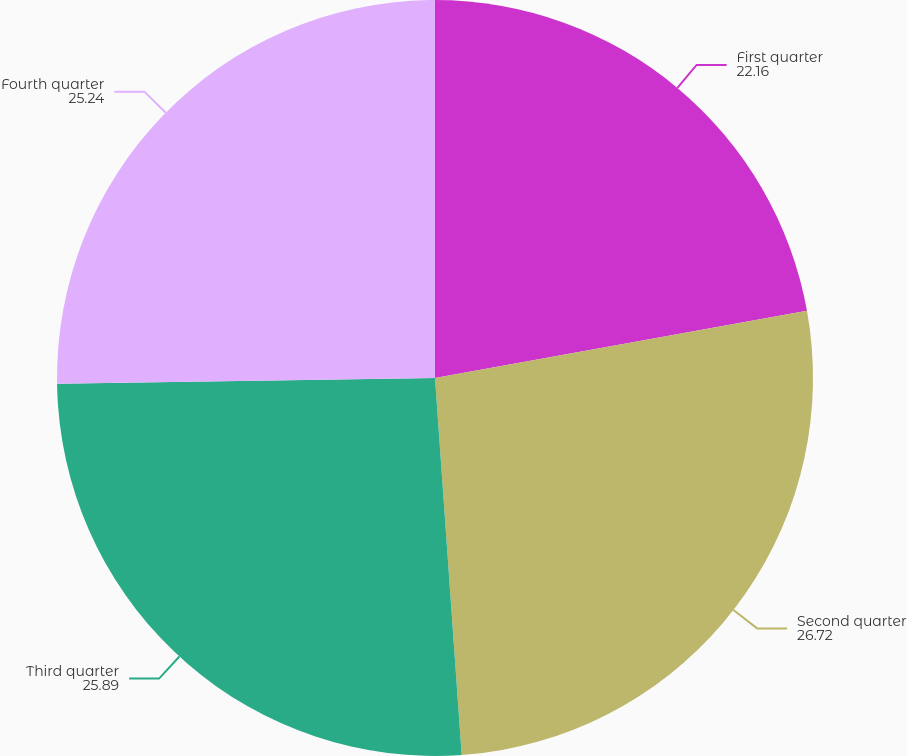<chart> <loc_0><loc_0><loc_500><loc_500><pie_chart><fcel>First quarter<fcel>Second quarter<fcel>Third quarter<fcel>Fourth quarter<nl><fcel>22.16%<fcel>26.72%<fcel>25.89%<fcel>25.24%<nl></chart> 